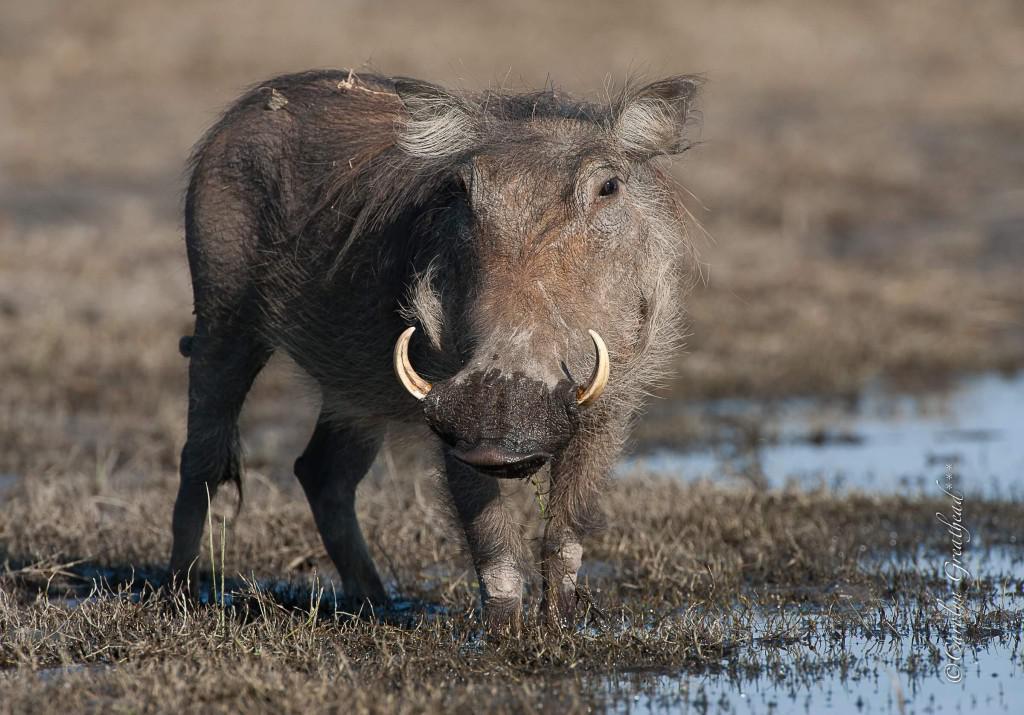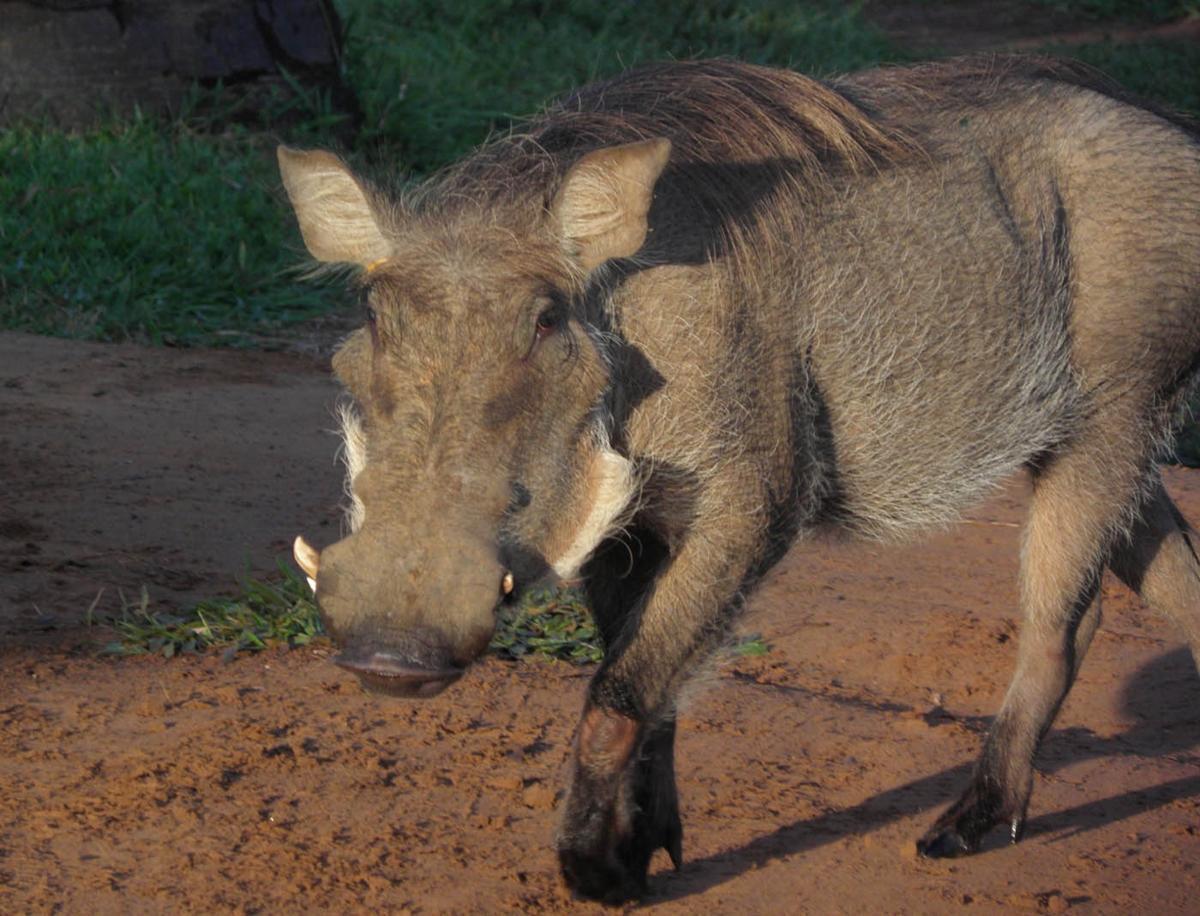The first image is the image on the left, the second image is the image on the right. Examine the images to the left and right. Is the description "There are two animals in the image on the left." accurate? Answer yes or no. No. 